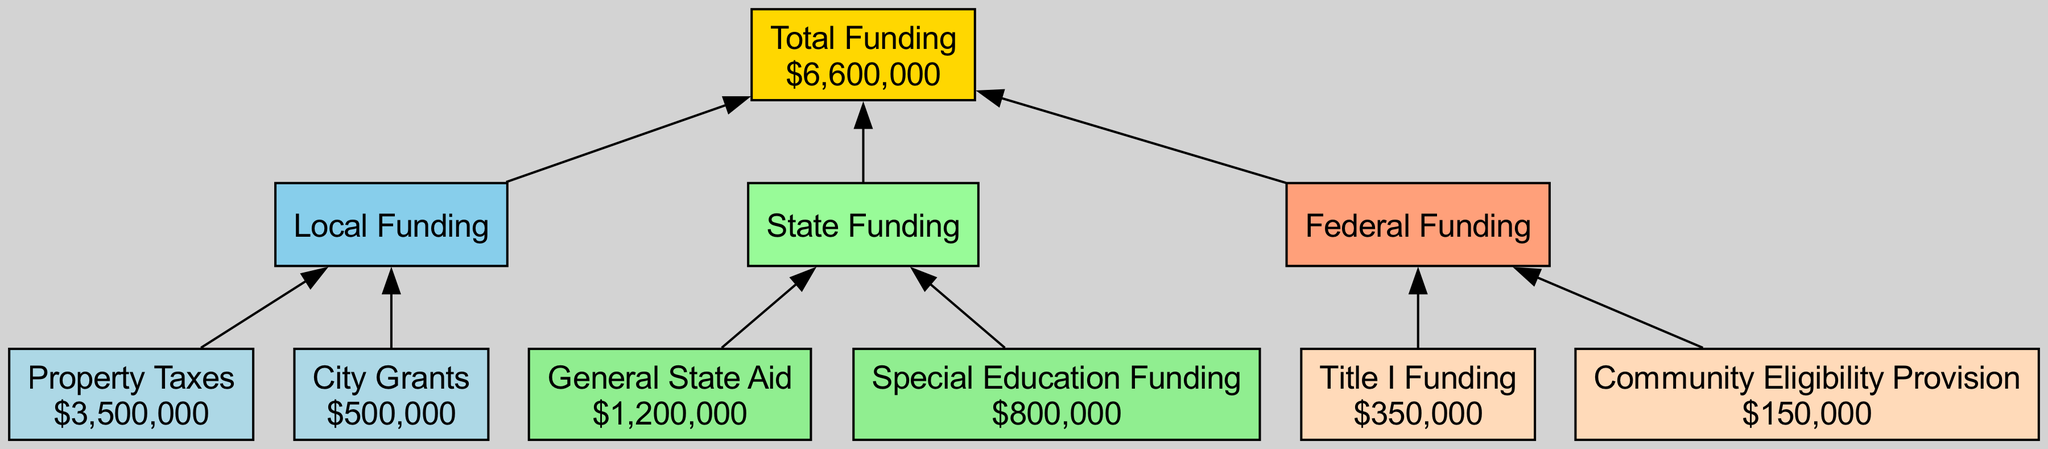What is the total funding amount for the school? The "Total Funding" node aggregates the amounts from local, state, and federal funding sources. The total process involves identifying the total amount node, which indicates "$6,600,000."
Answer: $6,600,000 How much does local funding contribute? The local funding node summarizes the contributions made by property taxes and city grants, displayed with the amount node showing "$4,000,000," combining both sources.
Answer: $4,000,000 Which source provides the most funding? The visual representation shows that property taxes provide the largest single contribution at "$3,500,000," which is clearly indicated under local funding.
Answer: Property Taxes What is the amount of General State Aid? The "General State Aid" node specifies an amount of "$1,200,000," highlighting this as a individual contribution within the state funding section.
Answer: $1,200,000 How many nodes are there in the diagram? The diagram consists of a total of 8 nodes, including the total funding node, local funding, state funding, federal funding, and their respective sources.
Answer: 8 What is the federal funding amount? The federal funding section shows two contributions, specifically "$350,000" from Title I and "$150,000" from the Community Eligibility Provision, totaling to "$500,000." This indicates the overall contribution from federal sources.
Answer: $500,000 Which funding source is designated for special needs programs? The "Special Education Funding" node is labeled specifically for state assistance related to special needs programs, showing an amount of "$800,000."
Answer: Special Education Funding What does the flow from local to total funding indicate? The edge connecting the local funding node to the total funding node shows that local contributions directly add to the total funding available for the school, reflecting the aggregation of all funding sources.
Answer: Aggregation Does federal funding or state funding contribute more to the total? Comparing the amounts, state funding contributes "$2,000,000" when you sum the general state aid and special education funding, whereas federal funding sums to "$500,000." Clearly, state funding brings in more to the total funding.
Answer: State Funding 